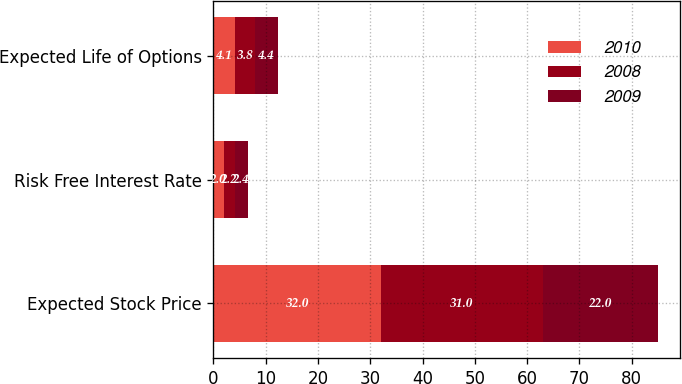Convert chart. <chart><loc_0><loc_0><loc_500><loc_500><stacked_bar_chart><ecel><fcel>Expected Stock Price<fcel>Risk Free Interest Rate<fcel>Expected Life of Options<nl><fcel>2010<fcel>32<fcel>2<fcel>4.1<nl><fcel>2008<fcel>31<fcel>2.2<fcel>3.8<nl><fcel>2009<fcel>22<fcel>2.4<fcel>4.4<nl></chart> 